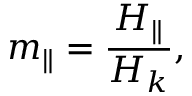<formula> <loc_0><loc_0><loc_500><loc_500>m _ { \| } = \frac { H _ { \| } } { H _ { k } } ,</formula> 